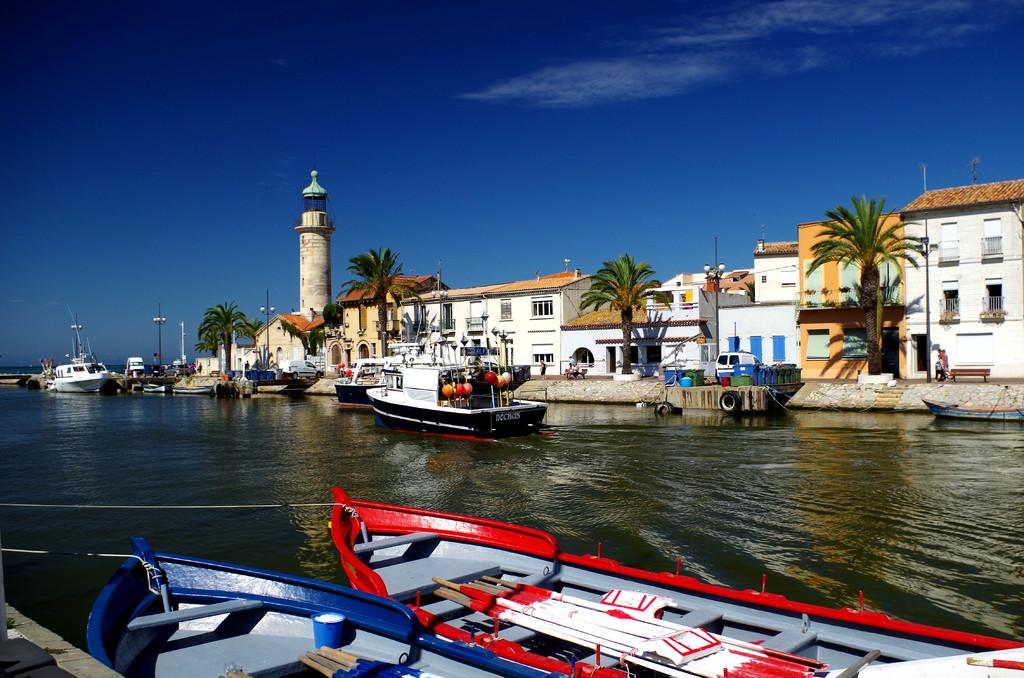What is on the water in the image? There are boats on the lake in the image. What can be seen in the distance behind the boats? There are trees and buildings in the background of the image. What structures are present in the image? There are poles in the image. How many clams are visible on the boats in the image? There are no clams visible on the boats in the image. What is the rate at which the boats are moving in the image? The image does not provide information about the speed or rate at which the boats are moving. 